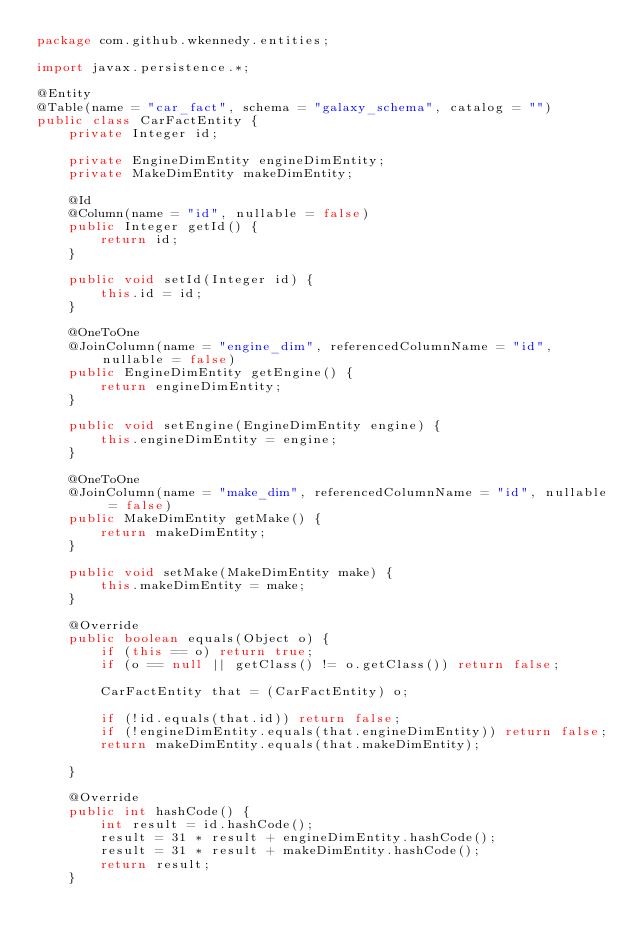Convert code to text. <code><loc_0><loc_0><loc_500><loc_500><_Java_>package com.github.wkennedy.entities;

import javax.persistence.*;

@Entity
@Table(name = "car_fact", schema = "galaxy_schema", catalog = "")
public class CarFactEntity {
    private Integer id;

    private EngineDimEntity engineDimEntity;
    private MakeDimEntity makeDimEntity;

    @Id
    @Column(name = "id", nullable = false)
    public Integer getId() {
        return id;
    }

    public void setId(Integer id) {
        this.id = id;
    }

    @OneToOne
    @JoinColumn(name = "engine_dim", referencedColumnName = "id", nullable = false)
    public EngineDimEntity getEngine() {
        return engineDimEntity;
    }

    public void setEngine(EngineDimEntity engine) {
        this.engineDimEntity = engine;
    }

    @OneToOne
    @JoinColumn(name = "make_dim", referencedColumnName = "id", nullable = false)
    public MakeDimEntity getMake() {
        return makeDimEntity;
    }

    public void setMake(MakeDimEntity make) {
        this.makeDimEntity = make;
    }

    @Override
    public boolean equals(Object o) {
        if (this == o) return true;
        if (o == null || getClass() != o.getClass()) return false;

        CarFactEntity that = (CarFactEntity) o;

        if (!id.equals(that.id)) return false;
        if (!engineDimEntity.equals(that.engineDimEntity)) return false;
        return makeDimEntity.equals(that.makeDimEntity);

    }

    @Override
    public int hashCode() {
        int result = id.hashCode();
        result = 31 * result + engineDimEntity.hashCode();
        result = 31 * result + makeDimEntity.hashCode();
        return result;
    }</code> 